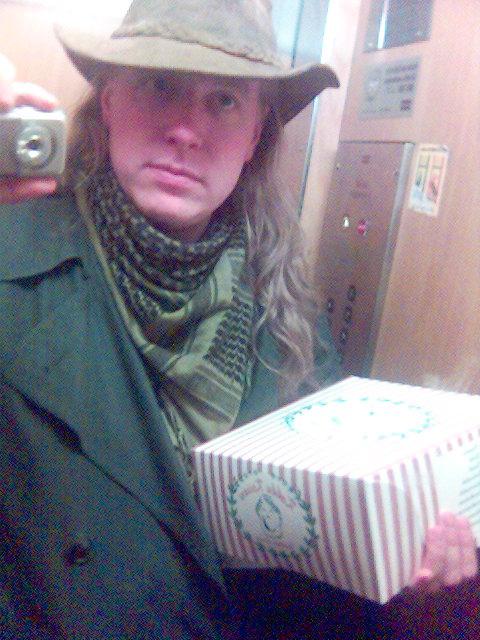What kind of hat is the man wearing?
Short answer required. Cowboy. What brand is in the cardboard box?
Keep it brief. Krispy kreme. What is this man holding in the photo?
Answer briefly. Box. Are these people happy?
Short answer required. No. What is on his head?
Answer briefly. Hat. Can you see through this woman's hat?
Answer briefly. No. What is in the person's left hand?
Write a very short answer. Box. Where was this photo taken?
Concise answer only. Elevator. What is on the man's face?
Be succinct. Nothing. Is this woman happy?
Answer briefly. No. What is the girl holding in her hands?
Keep it brief. Box. Is this a selfie?
Be succinct. Yes. 